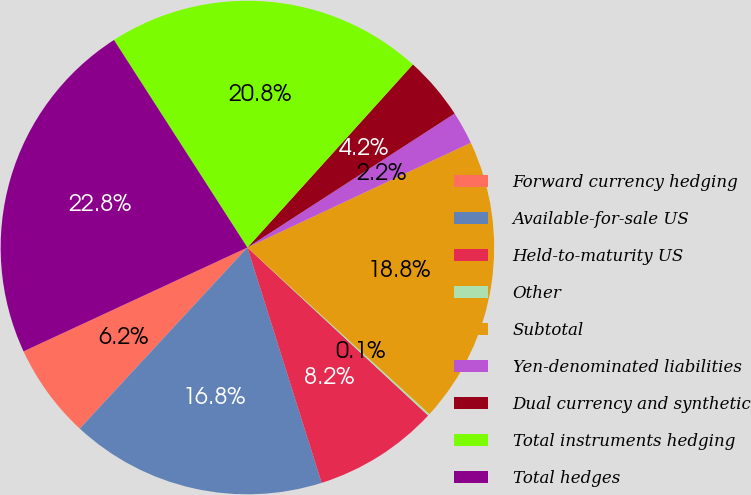Convert chart. <chart><loc_0><loc_0><loc_500><loc_500><pie_chart><fcel>Forward currency hedging<fcel>Available-for-sale US<fcel>Held-to-maturity US<fcel>Other<fcel>Subtotal<fcel>Yen-denominated liabilities<fcel>Dual currency and synthetic<fcel>Total instruments hedging<fcel>Total hedges<nl><fcel>6.2%<fcel>16.75%<fcel>8.22%<fcel>0.13%<fcel>18.77%<fcel>2.15%<fcel>4.17%<fcel>20.79%<fcel>22.82%<nl></chart> 